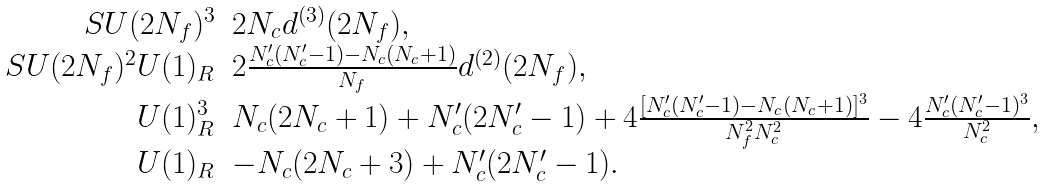Convert formula to latex. <formula><loc_0><loc_0><loc_500><loc_500>\begin{array} { r l } { { S U ( 2 N _ { f } ) ^ { 3 } } } & { { 2 N _ { c } d ^ { ( 3 ) } ( 2 N _ { f } ) , } } \\ { { S U ( 2 N _ { f } ) ^ { 2 } U ( 1 ) _ { R } } } & { { 2 \frac { N _ { c } ^ { \prime } ( N _ { c } ^ { \prime } - 1 ) - N _ { c } ( N _ { c } + 1 ) } { N _ { f } } d ^ { ( 2 ) } ( 2 N _ { f } ) , } } \\ { { U ( 1 ) _ { R } ^ { 3 } } } & { { N _ { c } ( 2 N _ { c } + 1 ) + N _ { c } ^ { \prime } ( 2 N _ { c } ^ { \prime } - 1 ) + 4 \frac { [ N _ { c } ^ { \prime } ( N _ { c } ^ { \prime } - 1 ) - N _ { c } ( N _ { c } + 1 ) ] ^ { 3 } } { N _ { f } ^ { 2 } N _ { c } ^ { 2 } } - 4 \frac { N _ { c } ^ { \prime } ( N _ { c } ^ { \prime } - 1 ) ^ { 3 } } { N _ { c } ^ { 2 } } , } } \\ { { U ( 1 ) _ { R } } } & { { - N _ { c } ( 2 N _ { c } + 3 ) + N _ { c } ^ { \prime } ( 2 N _ { c } ^ { \prime } - 1 ) . } } \end{array}</formula> 